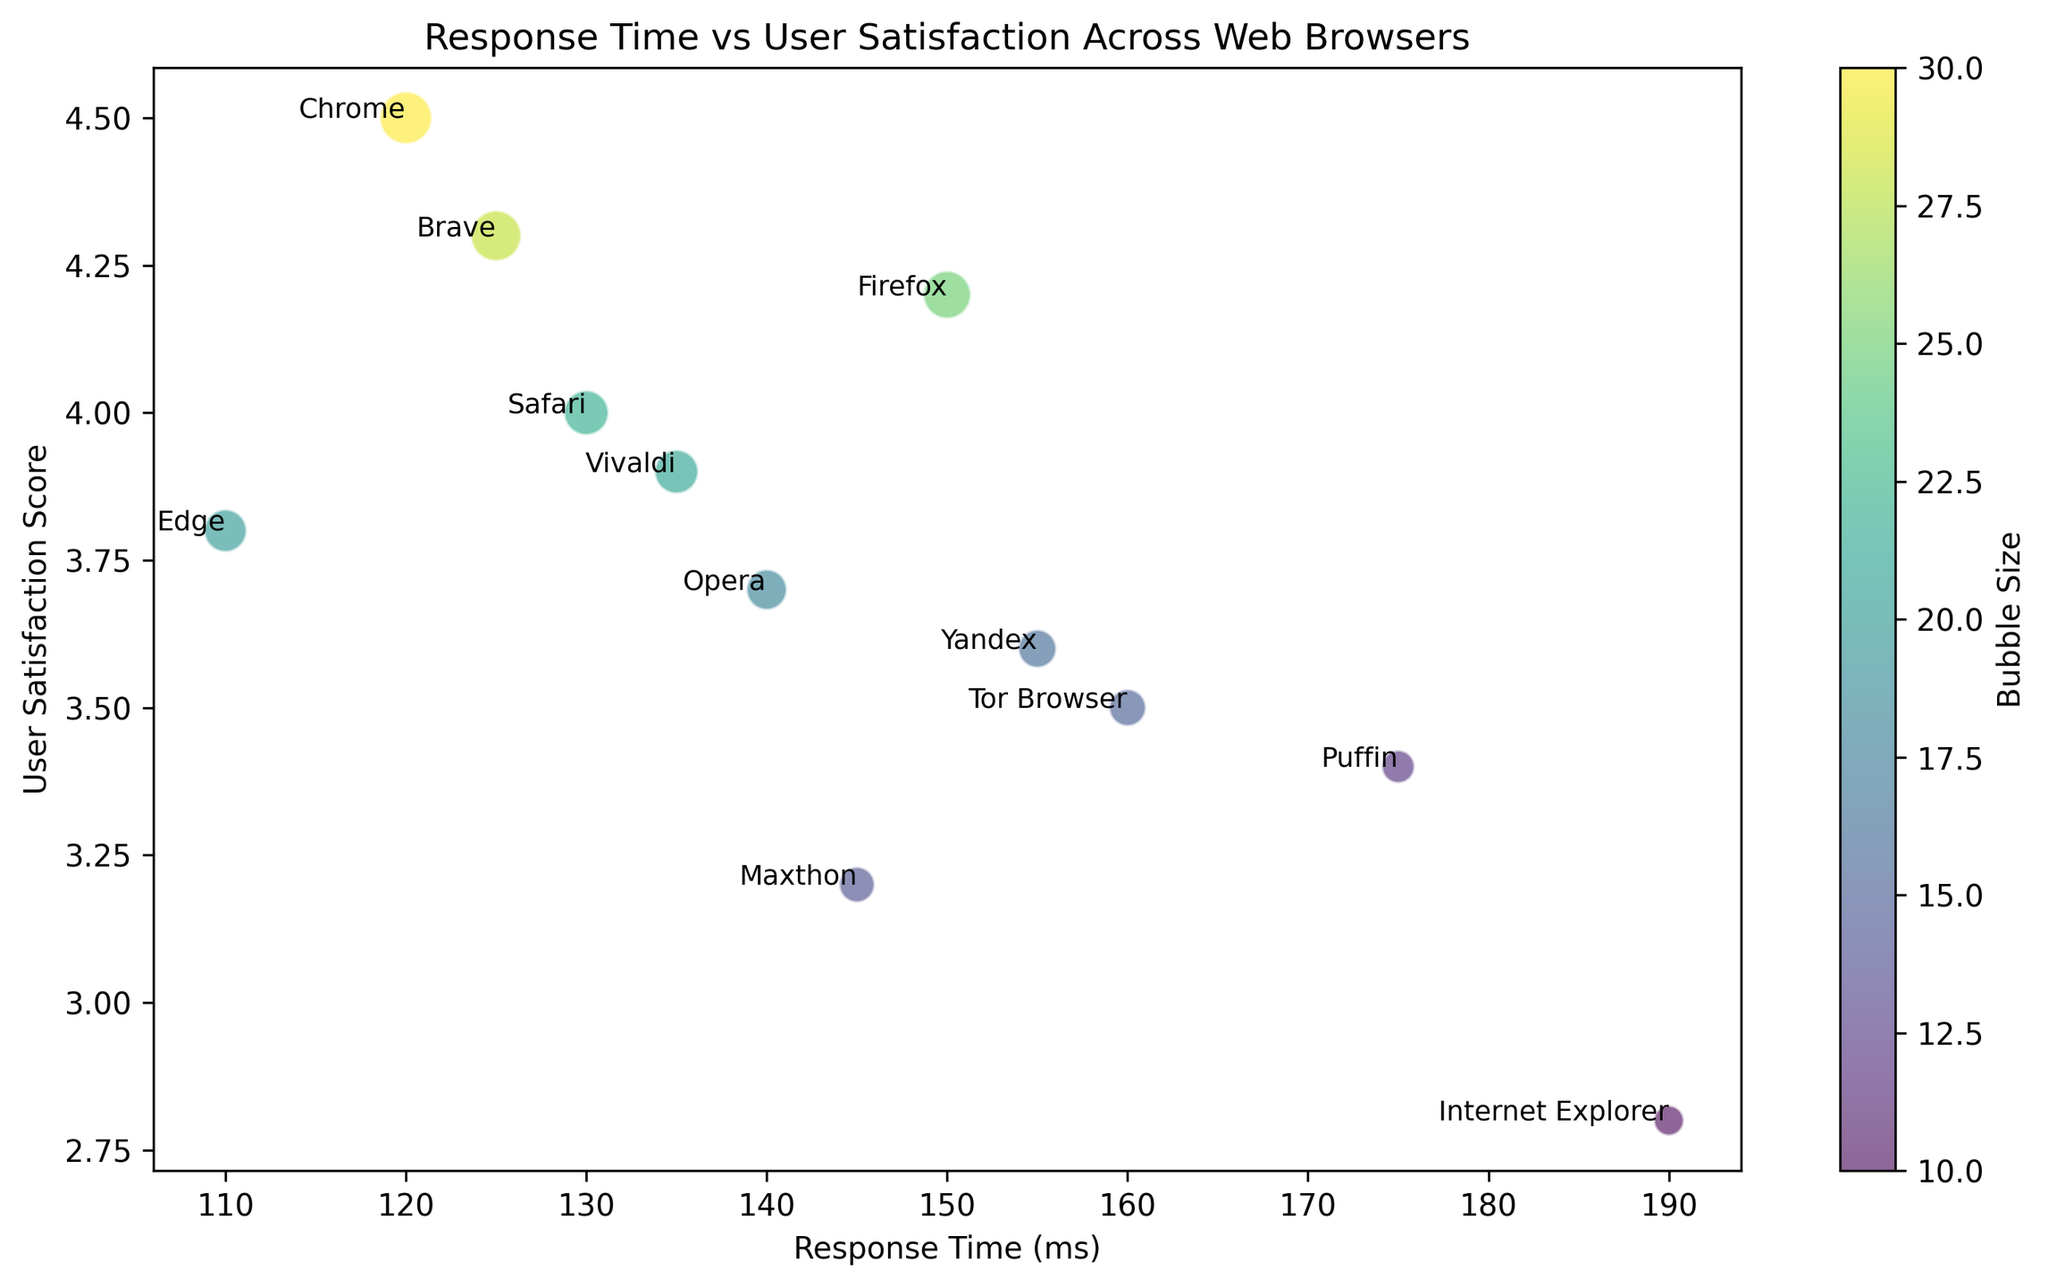Which browser offers the highest user satisfaction score? To determine the browser with the highest user satisfaction score, look for the highest point on the y-axis. Chrome has a user satisfaction score of 4.5, which is the highest among the browsers.
Answer: Chrome Which browser has the slowest response time? To find the browser with the slowest response time, check the point farthest to the right on the x-axis. Internet Explorer has a response time of 190 ms, making it the slowest.
Answer: Internet Explorer Compare the user satisfaction scores of Chrome and Firefox. Which one is higher and by how much? Chrome has a user satisfaction score of 4.5 and Firefox has 4.2. The difference can be found by subtracting 4.2 from 4.5. The satisfaction score for Chrome is higher by 0.3.
Answer: 0.3 What is the average user satisfaction score of Edge and Safari? Edge has a user satisfaction score of 3.8, and Safari has 4.0. To find the average, sum these two scores and divide by 2: (3.8 + 4.0) / 2 = 3.9.
Answer: 3.9 Which browser has the smallest bubble size? The bubble size represents the size of the circles in the chart. The smallest bubble corresponds to Internet Explorer, which has a bubble size of 10.
Answer: Internet Explorer What is the combined response time of Puffin and Tor Browser? Puffin has a response time of 175 ms, and Tor Browser has 160 ms. Adding these two times gives: 175 + 160 = 335 ms.
Answer: 335 ms If you only consider browsers with a user satisfaction score greater than 4.0, which browser has the largest response time? Browsers with a satisfaction score greater than 4.0 are Chrome (120 ms) and Brave (125 ms). Brave has the largest response time among these, which is 125 ms.
Answer: Brave List the browsers with a user satisfaction score below 3.5. Browsers with a user satisfaction score below 3.5 are Internet Explorer (2.8), Maxthon (3.2), and Puffin (3.4).
Answer: Internet Explorer, Maxthon, Puffin How does the response time of Edge compare with that of Vivaldi? Edge has a response time of 110 ms, while Vivaldi has 135 ms. Edge has a quicker response time compared to Vivaldi by 25 ms.
Answer: Edge by 25 ms Which browser has the lowest user satisfaction score, and what is its corresponding response time? The browser with the lowest user satisfaction score is Internet Explorer, with a score of 2.8. Its corresponding response time is 190 ms.
Answer: Internet Explorer, 190 ms 